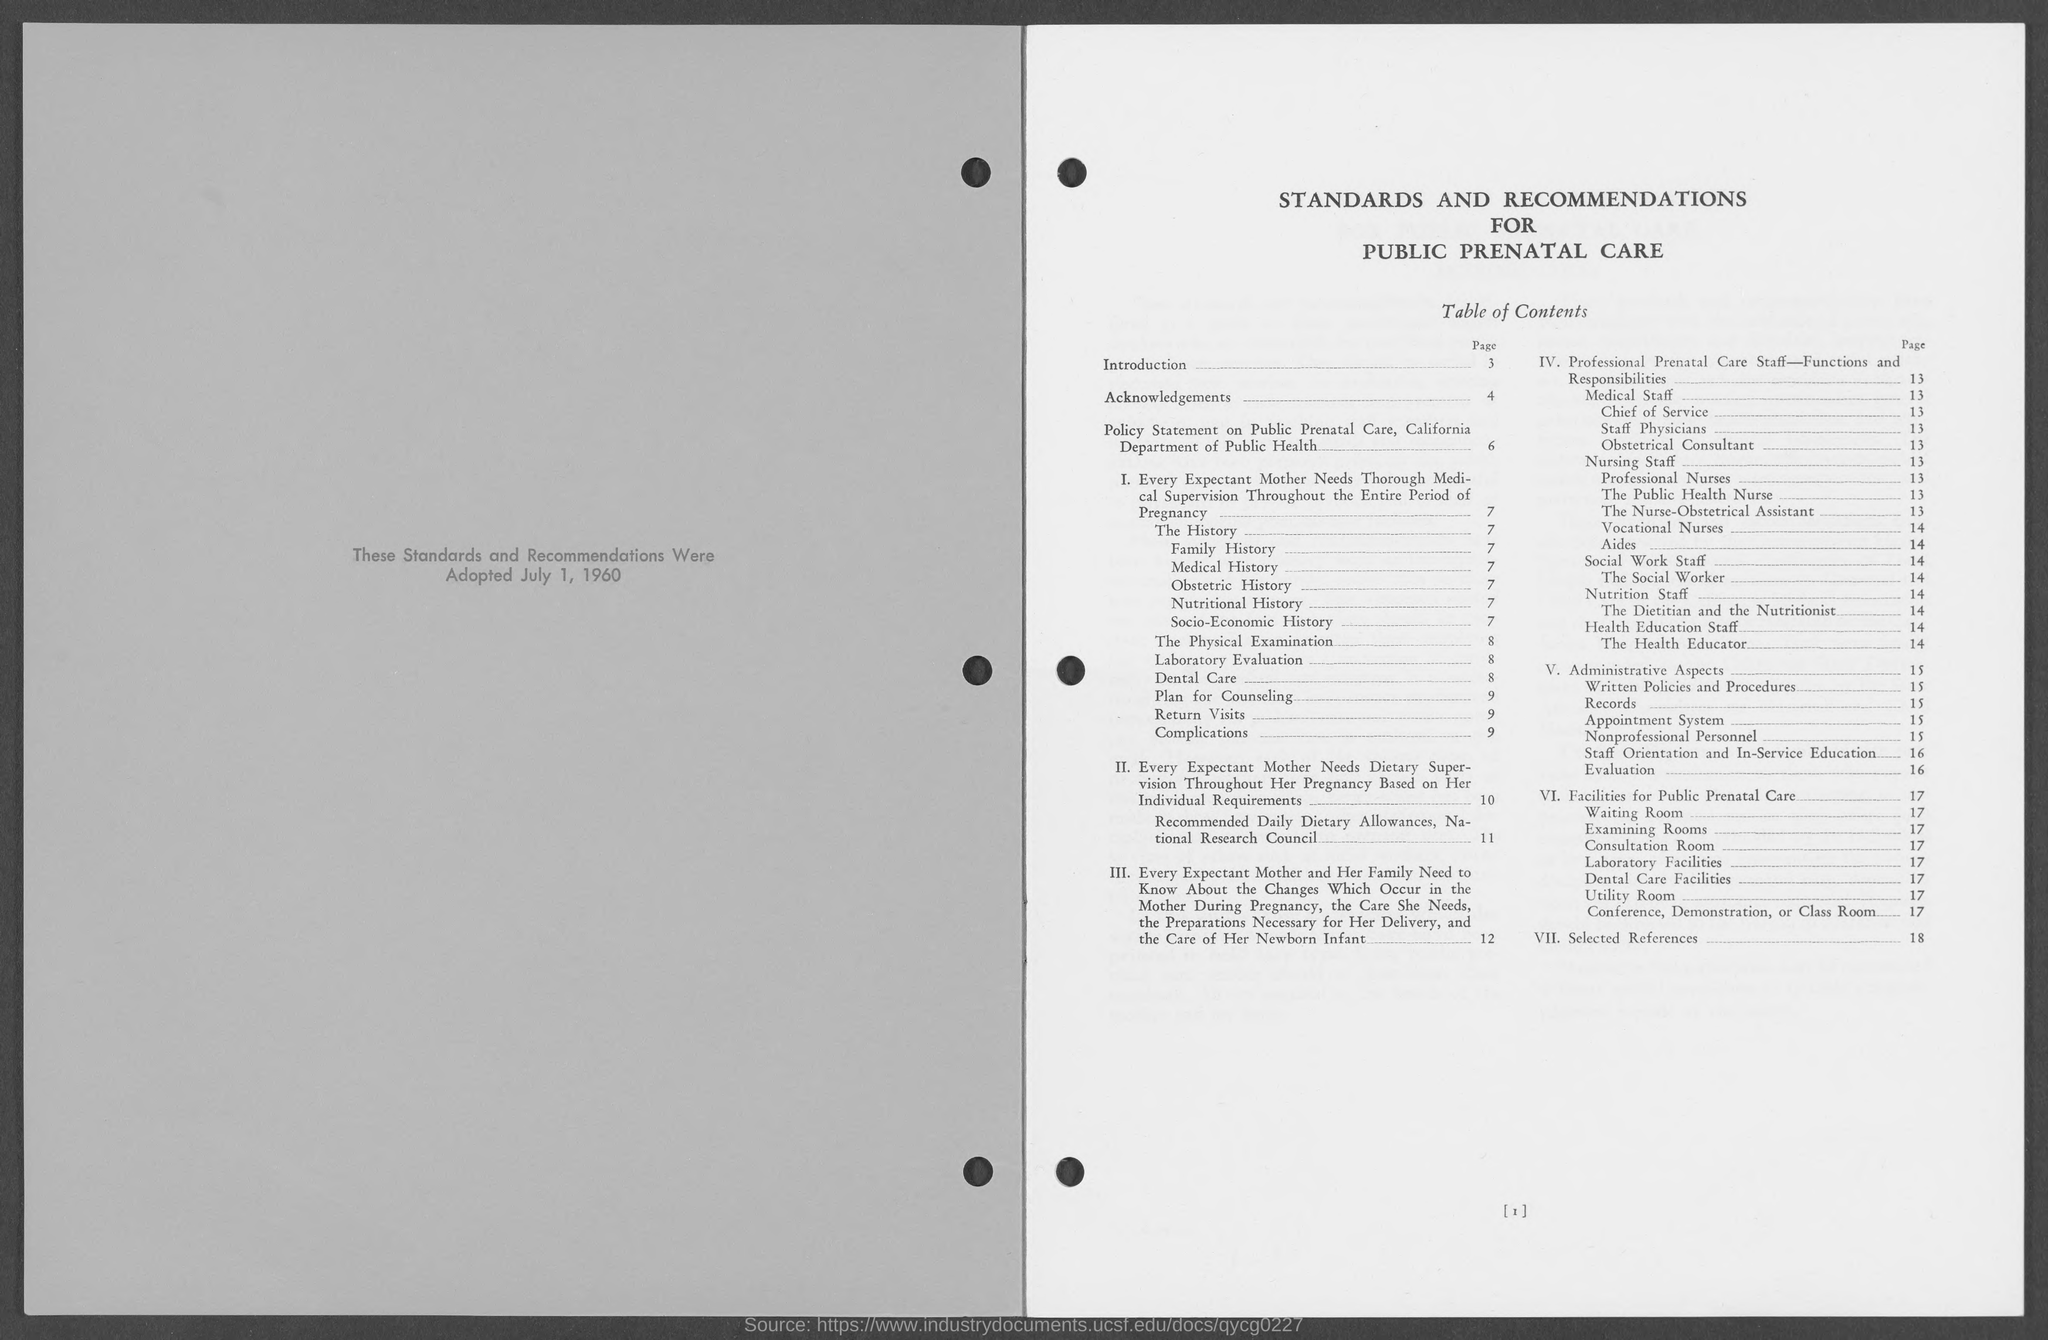Point out several critical features in this image. The topmost heading on the right-hand side of the document is 'Standards and Recommendations for Public Prenatal Care.' The date on the left-hand side of the document is July 1, 1960. The page number of the topic "Selected References" is 18. The page number of "Nursing staff" is 13. The page number of the topic "Nutritional History" is 7. 